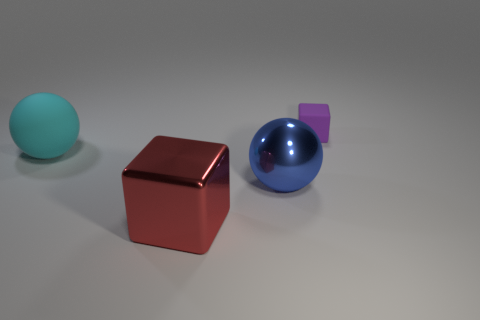Add 1 cyan matte balls. How many objects exist? 5 Subtract 0 purple balls. How many objects are left? 4 Subtract all large metal spheres. Subtract all big blue rubber objects. How many objects are left? 3 Add 1 big blocks. How many big blocks are left? 2 Add 3 red rubber cubes. How many red rubber cubes exist? 3 